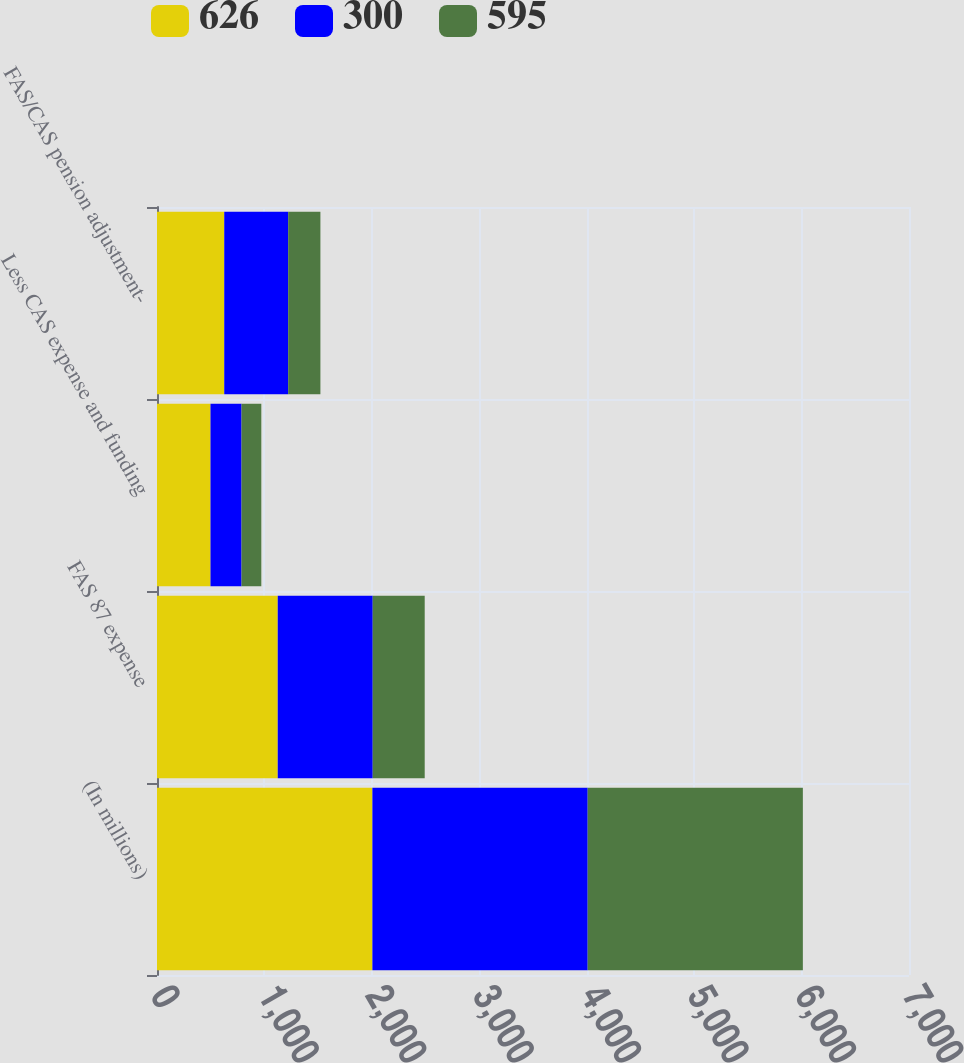Convert chart. <chart><loc_0><loc_0><loc_500><loc_500><stacked_bar_chart><ecel><fcel>(In millions)<fcel>FAS 87 expense<fcel>Less CAS expense and funding<fcel>FAS/CAS pension adjustment-<nl><fcel>626<fcel>2005<fcel>1124<fcel>498<fcel>626<nl><fcel>300<fcel>2004<fcel>884<fcel>289<fcel>595<nl><fcel>595<fcel>2003<fcel>484<fcel>184<fcel>300<nl></chart> 